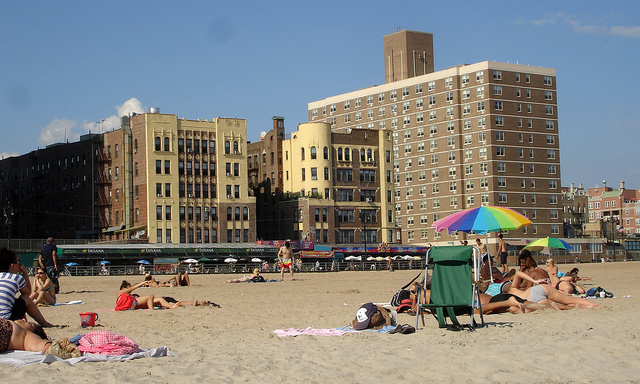Describe the overall atmosphere of this beach scene. The overall atmosphere appears to be quite relaxed and leisurely. Most beachgoers seem to be in a state of repose, indicating a tranquil and restful environment. The presence of buildings close to the beachfront provides a backdrop of urban beach life. There's a mix of individuals and small groups, suggesting that it's a locale welcoming to a variety of people looking to enjoy a day on the sand.  What kind of weather conditions can you infer from this image? The sky is mostly clear with very few clouds, indicating sunny weather conditions. People are dressed in summer attire, further supporting the notion of warm temperatures. The umbrellas open on the beach suggest a need for shade and protection from the sun's rays, hinting at a hot day typical of beach environments. 